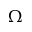<formula> <loc_0><loc_0><loc_500><loc_500>\Omega</formula> 